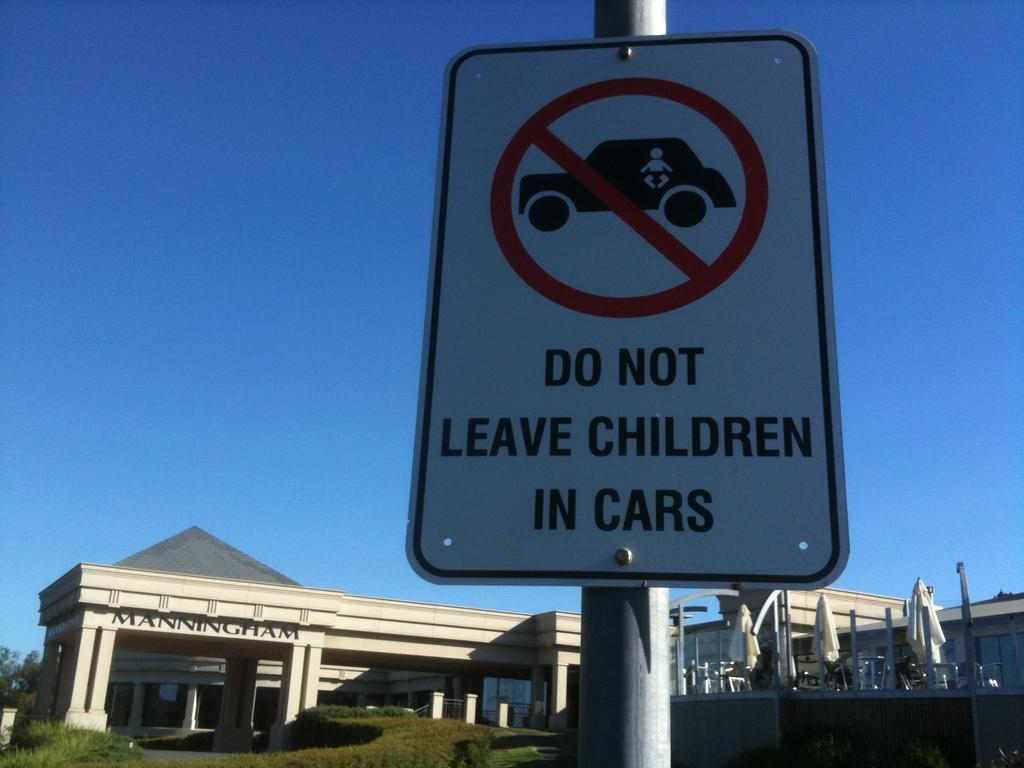Provide a one-sentence caption for the provided image. A sign in front of Manningham building reading "Do not leave children in cars". 